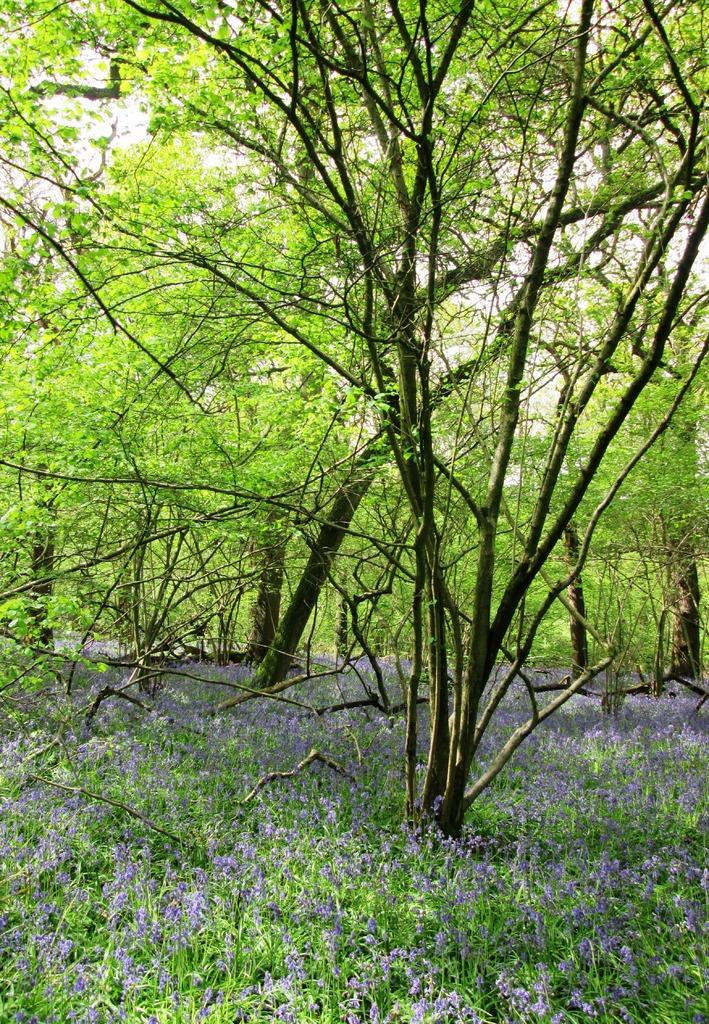What is located in the center of the image? There are trees, plants, grass, and flowers in the center of the image. What type of vegetation can be seen in the center of the image? There are trees, plants, and grass in the center of the image. What color are the flowers in the center of the image? The flowers in the center of the image are in violet color. Where is the coal being stored in the image? There is no coal present in the image. What type of clam can be seen in the image? There are no clams present in the image. 